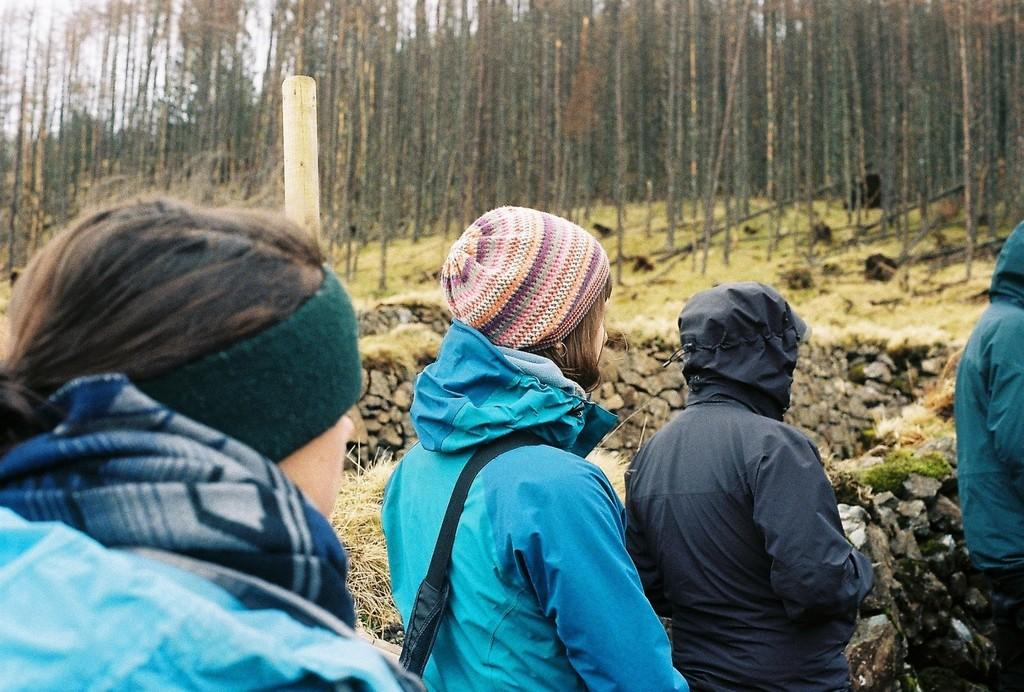Who or what can be seen in the image? There are people in the image. What type of structure is visible in the image? There is a stone wall in the image. What type of vegetation is present in the image? There is grass in the image. What object can be seen in the image, standing upright? There is a pole in the image. What can be seen in the background of the image? In the background, there are walls, grass, and trees. Where is the mailbox located in the image? There is no mailbox present in the image. What type of prison can be seen in the image? There is no prison present in the image. 